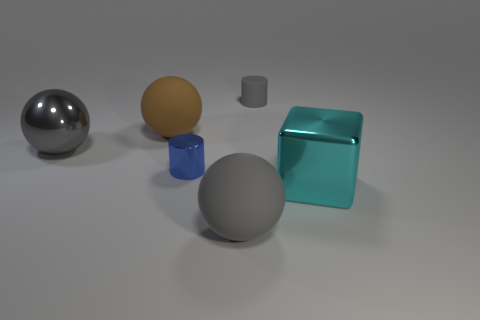What shape is the tiny thing that is the same color as the big metallic ball?
Provide a short and direct response. Cylinder. Is there any other thing that is the same material as the big cyan thing?
Make the answer very short. Yes. How many things are small yellow rubber objects or big gray spheres on the left side of the brown matte sphere?
Your answer should be very brief. 1. There is a gray ball right of the metal ball; is it the same size as the large brown ball?
Ensure brevity in your answer.  Yes. How many other objects are there of the same shape as the big brown matte object?
Your answer should be compact. 2. What number of green objects are rubber objects or tiny metallic cylinders?
Ensure brevity in your answer.  0. There is a ball that is in front of the big cube; does it have the same color as the big metal sphere?
Provide a short and direct response. Yes. What shape is the large gray thing that is made of the same material as the large cyan block?
Offer a terse response. Sphere. The rubber thing that is on the right side of the large brown thing and behind the cyan block is what color?
Your answer should be compact. Gray. What is the size of the cylinder to the left of the big gray matte sphere right of the tiny blue cylinder?
Provide a short and direct response. Small. 